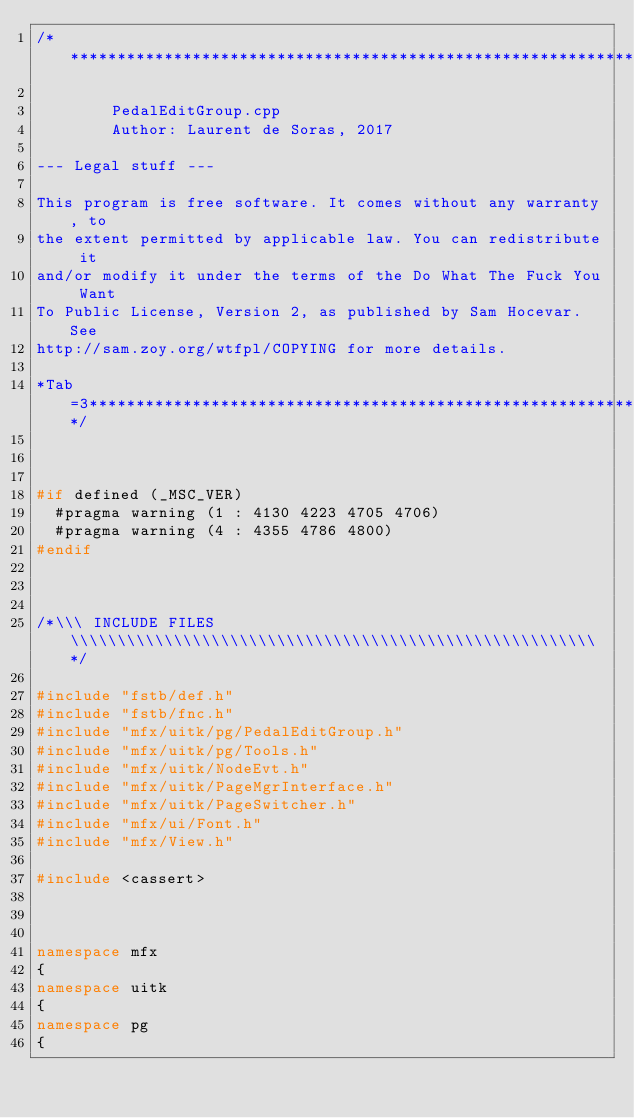<code> <loc_0><loc_0><loc_500><loc_500><_C++_>/*****************************************************************************

        PedalEditGroup.cpp
        Author: Laurent de Soras, 2017

--- Legal stuff ---

This program is free software. It comes without any warranty, to
the extent permitted by applicable law. You can redistribute it
and/or modify it under the terms of the Do What The Fuck You Want
To Public License, Version 2, as published by Sam Hocevar. See
http://sam.zoy.org/wtfpl/COPYING for more details.

*Tab=3***********************************************************************/



#if defined (_MSC_VER)
	#pragma warning (1 : 4130 4223 4705 4706)
	#pragma warning (4 : 4355 4786 4800)
#endif



/*\\\ INCLUDE FILES \\\\\\\\\\\\\\\\\\\\\\\\\\\\\\\\\\\\\\\\\\\\\\\\\\\\\\\\*/

#include "fstb/def.h"
#include "fstb/fnc.h"
#include "mfx/uitk/pg/PedalEditGroup.h"
#include "mfx/uitk/pg/Tools.h"
#include "mfx/uitk/NodeEvt.h"
#include "mfx/uitk/PageMgrInterface.h"
#include "mfx/uitk/PageSwitcher.h"
#include "mfx/ui/Font.h"
#include "mfx/View.h"

#include <cassert>



namespace mfx
{
namespace uitk
{
namespace pg
{


</code> 